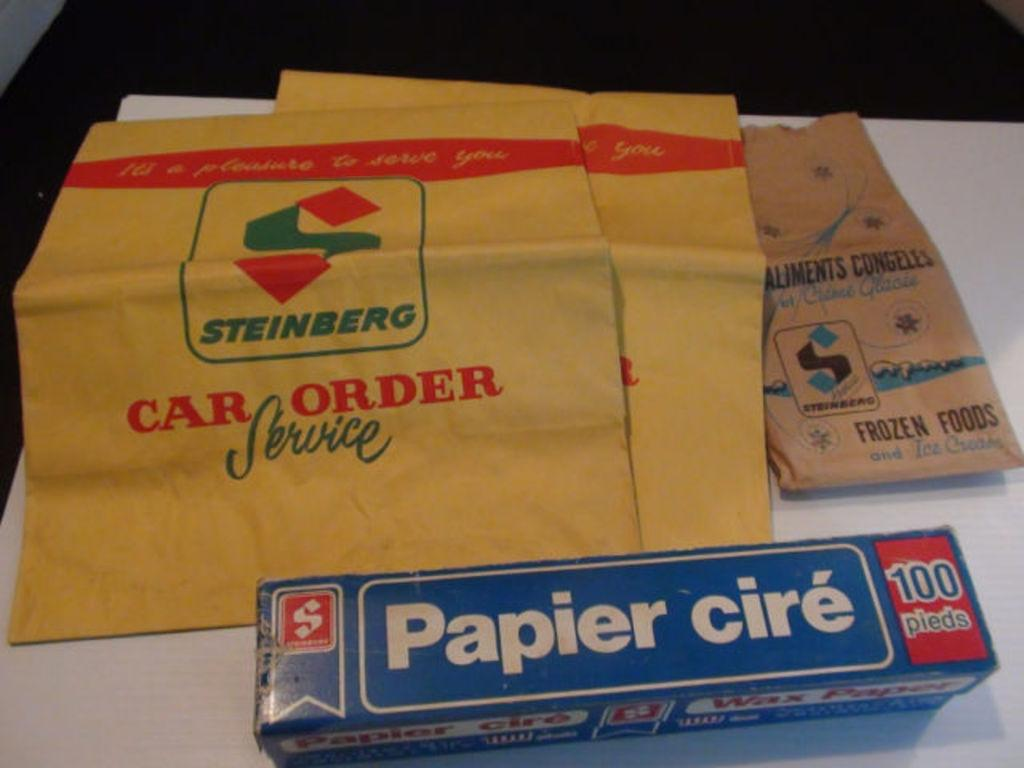<image>
Present a compact description of the photo's key features. a box of Papier cire sitting in front of some Steinberg bags 